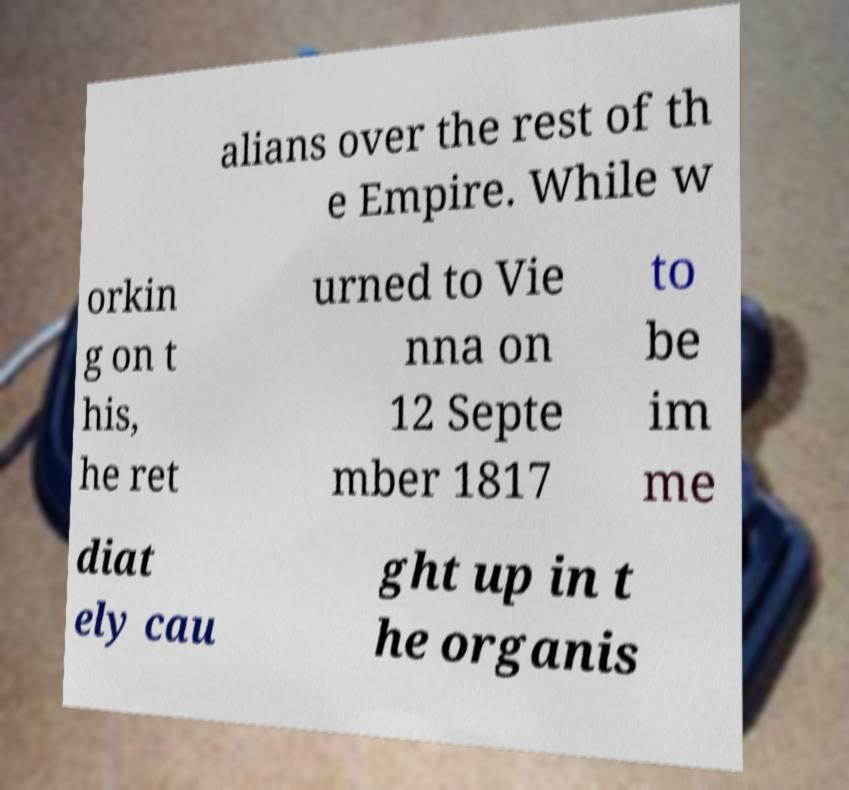For documentation purposes, I need the text within this image transcribed. Could you provide that? alians over the rest of th e Empire. While w orkin g on t his, he ret urned to Vie nna on 12 Septe mber 1817 to be im me diat ely cau ght up in t he organis 